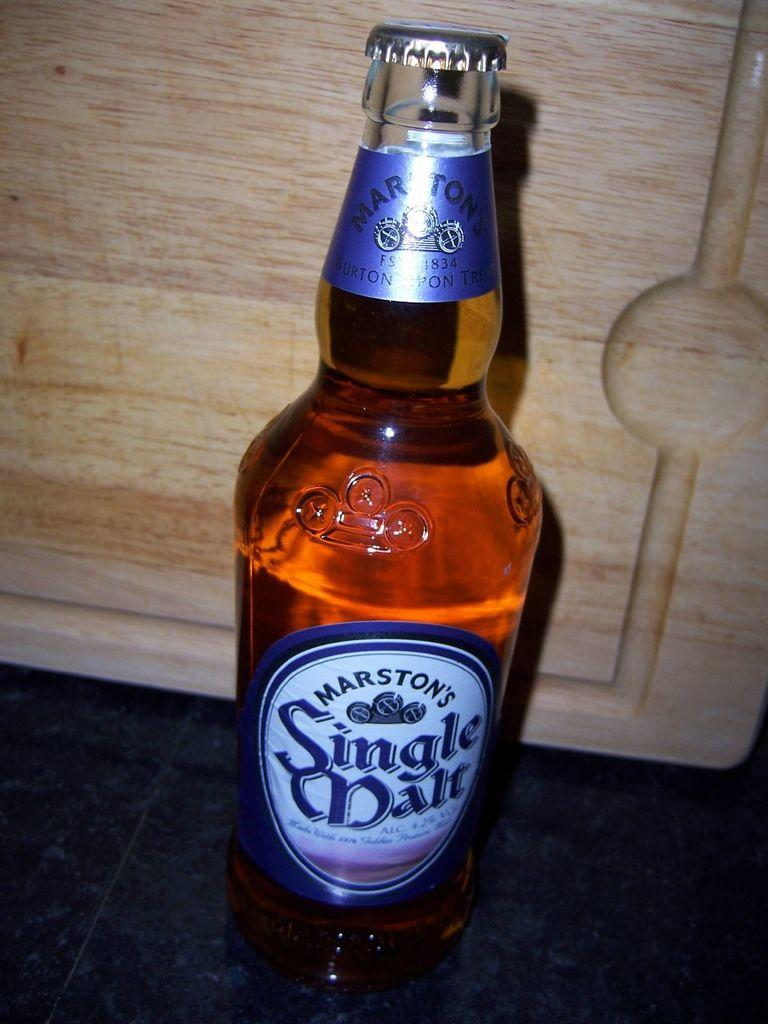What is the main object in the image? There is a beer bottle in the image. What is the condition of the cap on the beer bottle? The beer bottle has a closed metal cap. What can be found on the surface of the beer bottle? There is a label attached to the bottle. Where is the beer bottle located in the image? The bottle is placed on the floor. What type of object can be seen in the background of the image? There is a wooden object in the background of the image. Can you see a farmer kissing death in the image? No, there is no farmer or death depicted in the image; it only features a beer bottle with a closed metal cap, a label, and a wooden object in the background. 